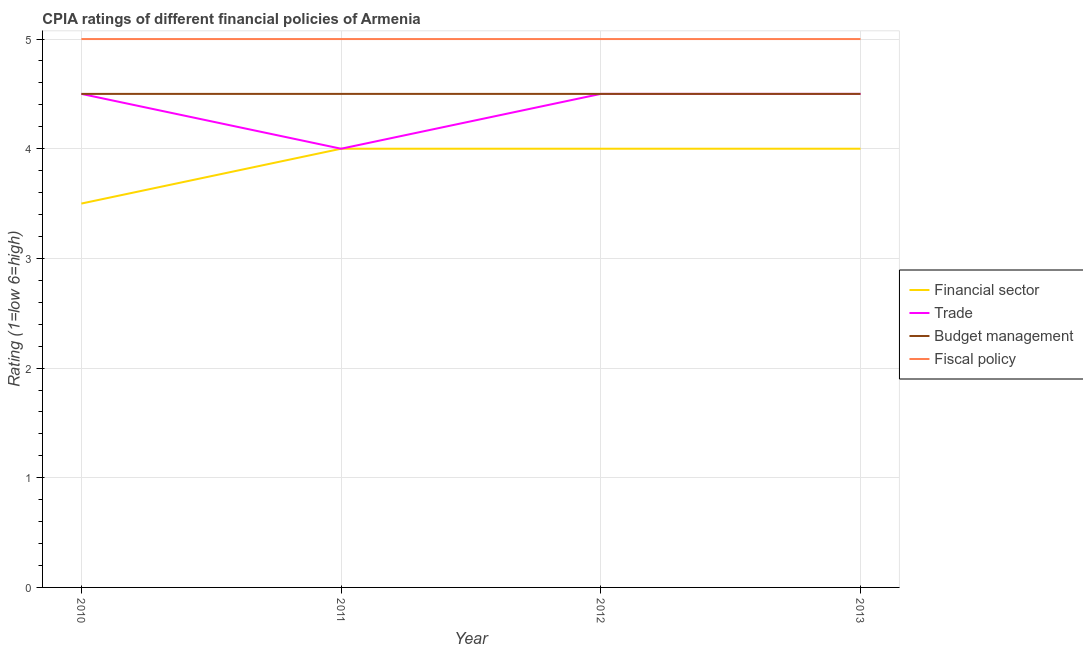How many different coloured lines are there?
Provide a succinct answer. 4. What is the cpia rating of financial sector in 2010?
Your answer should be very brief. 3.5. Across all years, what is the maximum cpia rating of fiscal policy?
Offer a terse response. 5. In which year was the cpia rating of trade maximum?
Ensure brevity in your answer.  2010. In which year was the cpia rating of fiscal policy minimum?
Provide a short and direct response. 2010. What is the average cpia rating of financial sector per year?
Make the answer very short. 3.88. In how many years, is the cpia rating of financial sector greater than 3.4?
Keep it short and to the point. 4. What is the ratio of the cpia rating of budget management in 2010 to that in 2013?
Keep it short and to the point. 1. Is the cpia rating of financial sector in 2010 less than that in 2012?
Provide a short and direct response. Yes. In how many years, is the cpia rating of financial sector greater than the average cpia rating of financial sector taken over all years?
Your answer should be very brief. 3. Is it the case that in every year, the sum of the cpia rating of financial sector and cpia rating of fiscal policy is greater than the sum of cpia rating of budget management and cpia rating of trade?
Provide a short and direct response. No. Is it the case that in every year, the sum of the cpia rating of financial sector and cpia rating of trade is greater than the cpia rating of budget management?
Ensure brevity in your answer.  Yes. Is the cpia rating of trade strictly greater than the cpia rating of fiscal policy over the years?
Your answer should be compact. No. Does the graph contain grids?
Provide a succinct answer. Yes. Where does the legend appear in the graph?
Ensure brevity in your answer.  Center right. How many legend labels are there?
Give a very brief answer. 4. What is the title of the graph?
Make the answer very short. CPIA ratings of different financial policies of Armenia. Does "Arable land" appear as one of the legend labels in the graph?
Provide a succinct answer. No. What is the label or title of the X-axis?
Offer a terse response. Year. What is the label or title of the Y-axis?
Ensure brevity in your answer.  Rating (1=low 6=high). What is the Rating (1=low 6=high) in Budget management in 2010?
Offer a terse response. 4.5. What is the Rating (1=low 6=high) of Fiscal policy in 2010?
Offer a terse response. 5. What is the Rating (1=low 6=high) of Financial sector in 2011?
Give a very brief answer. 4. What is the Rating (1=low 6=high) of Trade in 2011?
Offer a terse response. 4. What is the Rating (1=low 6=high) in Budget management in 2011?
Your answer should be very brief. 4.5. What is the Rating (1=low 6=high) in Fiscal policy in 2011?
Your answer should be very brief. 5. What is the Rating (1=low 6=high) of Budget management in 2012?
Ensure brevity in your answer.  4.5. What is the Rating (1=low 6=high) of Financial sector in 2013?
Give a very brief answer. 4. What is the Rating (1=low 6=high) of Fiscal policy in 2013?
Your answer should be very brief. 5. Across all years, what is the maximum Rating (1=low 6=high) of Financial sector?
Offer a terse response. 4. Across all years, what is the maximum Rating (1=low 6=high) in Trade?
Provide a short and direct response. 4.5. Across all years, what is the maximum Rating (1=low 6=high) of Budget management?
Provide a short and direct response. 4.5. Across all years, what is the minimum Rating (1=low 6=high) in Financial sector?
Your answer should be very brief. 3.5. What is the total Rating (1=low 6=high) in Financial sector in the graph?
Your answer should be compact. 15.5. What is the difference between the Rating (1=low 6=high) of Trade in 2010 and that in 2011?
Your response must be concise. 0.5. What is the difference between the Rating (1=low 6=high) in Budget management in 2010 and that in 2011?
Offer a very short reply. 0. What is the difference between the Rating (1=low 6=high) of Fiscal policy in 2010 and that in 2011?
Your response must be concise. 0. What is the difference between the Rating (1=low 6=high) in Trade in 2010 and that in 2012?
Your response must be concise. 0. What is the difference between the Rating (1=low 6=high) in Fiscal policy in 2010 and that in 2012?
Ensure brevity in your answer.  0. What is the difference between the Rating (1=low 6=high) of Financial sector in 2010 and that in 2013?
Provide a short and direct response. -0.5. What is the difference between the Rating (1=low 6=high) of Trade in 2010 and that in 2013?
Provide a succinct answer. 0. What is the difference between the Rating (1=low 6=high) of Financial sector in 2011 and that in 2013?
Give a very brief answer. 0. What is the difference between the Rating (1=low 6=high) of Financial sector in 2012 and that in 2013?
Your answer should be very brief. 0. What is the difference between the Rating (1=low 6=high) of Trade in 2012 and that in 2013?
Your response must be concise. 0. What is the difference between the Rating (1=low 6=high) of Budget management in 2012 and that in 2013?
Your answer should be compact. 0. What is the difference between the Rating (1=low 6=high) in Fiscal policy in 2012 and that in 2013?
Offer a very short reply. 0. What is the difference between the Rating (1=low 6=high) of Financial sector in 2010 and the Rating (1=low 6=high) of Budget management in 2011?
Your answer should be compact. -1. What is the difference between the Rating (1=low 6=high) of Financial sector in 2010 and the Rating (1=low 6=high) of Fiscal policy in 2011?
Offer a terse response. -1.5. What is the difference between the Rating (1=low 6=high) of Trade in 2010 and the Rating (1=low 6=high) of Fiscal policy in 2011?
Offer a very short reply. -0.5. What is the difference between the Rating (1=low 6=high) in Budget management in 2010 and the Rating (1=low 6=high) in Fiscal policy in 2011?
Your response must be concise. -0.5. What is the difference between the Rating (1=low 6=high) of Trade in 2010 and the Rating (1=low 6=high) of Fiscal policy in 2012?
Your response must be concise. -0.5. What is the difference between the Rating (1=low 6=high) in Budget management in 2010 and the Rating (1=low 6=high) in Fiscal policy in 2012?
Your answer should be compact. -0.5. What is the difference between the Rating (1=low 6=high) of Financial sector in 2010 and the Rating (1=low 6=high) of Trade in 2013?
Your response must be concise. -1. What is the difference between the Rating (1=low 6=high) of Trade in 2010 and the Rating (1=low 6=high) of Budget management in 2013?
Keep it short and to the point. 0. What is the difference between the Rating (1=low 6=high) in Financial sector in 2011 and the Rating (1=low 6=high) in Fiscal policy in 2012?
Ensure brevity in your answer.  -1. What is the difference between the Rating (1=low 6=high) in Trade in 2011 and the Rating (1=low 6=high) in Budget management in 2012?
Offer a terse response. -0.5. What is the difference between the Rating (1=low 6=high) in Budget management in 2011 and the Rating (1=low 6=high) in Fiscal policy in 2012?
Provide a succinct answer. -0.5. What is the difference between the Rating (1=low 6=high) in Financial sector in 2011 and the Rating (1=low 6=high) in Budget management in 2013?
Your response must be concise. -0.5. What is the difference between the Rating (1=low 6=high) of Financial sector in 2011 and the Rating (1=low 6=high) of Fiscal policy in 2013?
Ensure brevity in your answer.  -1. What is the difference between the Rating (1=low 6=high) in Trade in 2011 and the Rating (1=low 6=high) in Budget management in 2013?
Give a very brief answer. -0.5. What is the difference between the Rating (1=low 6=high) of Trade in 2012 and the Rating (1=low 6=high) of Budget management in 2013?
Your response must be concise. 0. What is the average Rating (1=low 6=high) of Financial sector per year?
Ensure brevity in your answer.  3.88. What is the average Rating (1=low 6=high) of Trade per year?
Keep it short and to the point. 4.38. What is the average Rating (1=low 6=high) in Budget management per year?
Provide a succinct answer. 4.5. What is the average Rating (1=low 6=high) in Fiscal policy per year?
Offer a very short reply. 5. In the year 2010, what is the difference between the Rating (1=low 6=high) in Financial sector and Rating (1=low 6=high) in Trade?
Offer a very short reply. -1. In the year 2011, what is the difference between the Rating (1=low 6=high) in Financial sector and Rating (1=low 6=high) in Trade?
Give a very brief answer. 0. In the year 2011, what is the difference between the Rating (1=low 6=high) in Financial sector and Rating (1=low 6=high) in Budget management?
Keep it short and to the point. -0.5. In the year 2011, what is the difference between the Rating (1=low 6=high) of Budget management and Rating (1=low 6=high) of Fiscal policy?
Make the answer very short. -0.5. In the year 2012, what is the difference between the Rating (1=low 6=high) of Financial sector and Rating (1=low 6=high) of Budget management?
Your response must be concise. -0.5. In the year 2012, what is the difference between the Rating (1=low 6=high) of Budget management and Rating (1=low 6=high) of Fiscal policy?
Make the answer very short. -0.5. In the year 2013, what is the difference between the Rating (1=low 6=high) in Financial sector and Rating (1=low 6=high) in Trade?
Give a very brief answer. -0.5. In the year 2013, what is the difference between the Rating (1=low 6=high) of Trade and Rating (1=low 6=high) of Budget management?
Ensure brevity in your answer.  0. In the year 2013, what is the difference between the Rating (1=low 6=high) of Budget management and Rating (1=low 6=high) of Fiscal policy?
Make the answer very short. -0.5. What is the ratio of the Rating (1=low 6=high) of Financial sector in 2010 to that in 2011?
Your response must be concise. 0.88. What is the ratio of the Rating (1=low 6=high) in Financial sector in 2010 to that in 2012?
Your answer should be very brief. 0.88. What is the ratio of the Rating (1=low 6=high) of Budget management in 2010 to that in 2012?
Ensure brevity in your answer.  1. What is the ratio of the Rating (1=low 6=high) of Financial sector in 2010 to that in 2013?
Ensure brevity in your answer.  0.88. What is the ratio of the Rating (1=low 6=high) in Budget management in 2010 to that in 2013?
Your answer should be very brief. 1. What is the ratio of the Rating (1=low 6=high) in Financial sector in 2011 to that in 2012?
Your answer should be very brief. 1. What is the ratio of the Rating (1=low 6=high) of Trade in 2011 to that in 2012?
Give a very brief answer. 0.89. What is the ratio of the Rating (1=low 6=high) in Budget management in 2011 to that in 2012?
Make the answer very short. 1. What is the ratio of the Rating (1=low 6=high) of Trade in 2011 to that in 2013?
Provide a short and direct response. 0.89. What is the ratio of the Rating (1=low 6=high) in Budget management in 2011 to that in 2013?
Your answer should be compact. 1. What is the ratio of the Rating (1=low 6=high) of Fiscal policy in 2011 to that in 2013?
Provide a short and direct response. 1. What is the ratio of the Rating (1=low 6=high) in Budget management in 2012 to that in 2013?
Offer a terse response. 1. What is the difference between the highest and the second highest Rating (1=low 6=high) of Financial sector?
Make the answer very short. 0. What is the difference between the highest and the second highest Rating (1=low 6=high) in Fiscal policy?
Your answer should be compact. 0. What is the difference between the highest and the lowest Rating (1=low 6=high) of Budget management?
Provide a succinct answer. 0. 